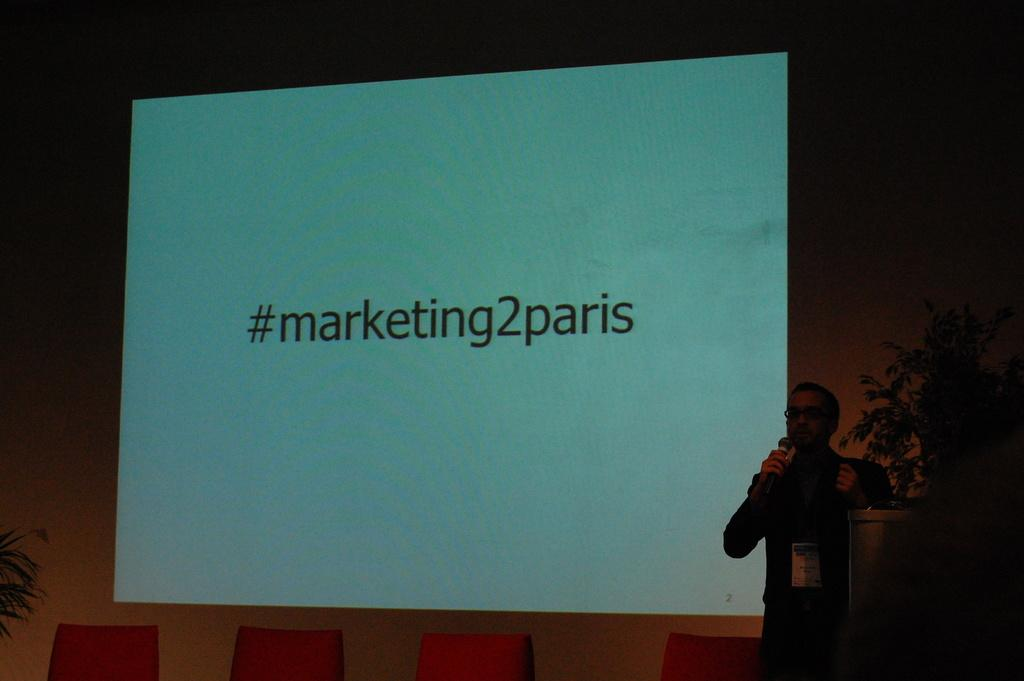What is the person in the image doing? The person is standing in the image and holding microphones. What object can be seen near the person? There is a podium in the image. What type of decorative items are present in the image? There are flower pots in the image. What can be used for displaying information or visuals in the image? There is a screen in the image. What type of furniture is present in the image? There are chairs in the image. What type of spade is being used by the person in the image? There is no spade present in the image; the person is holding microphones. What is the name of the person in the image? The name of the person in the image is not mentioned or visible, so it cannot be determined. 